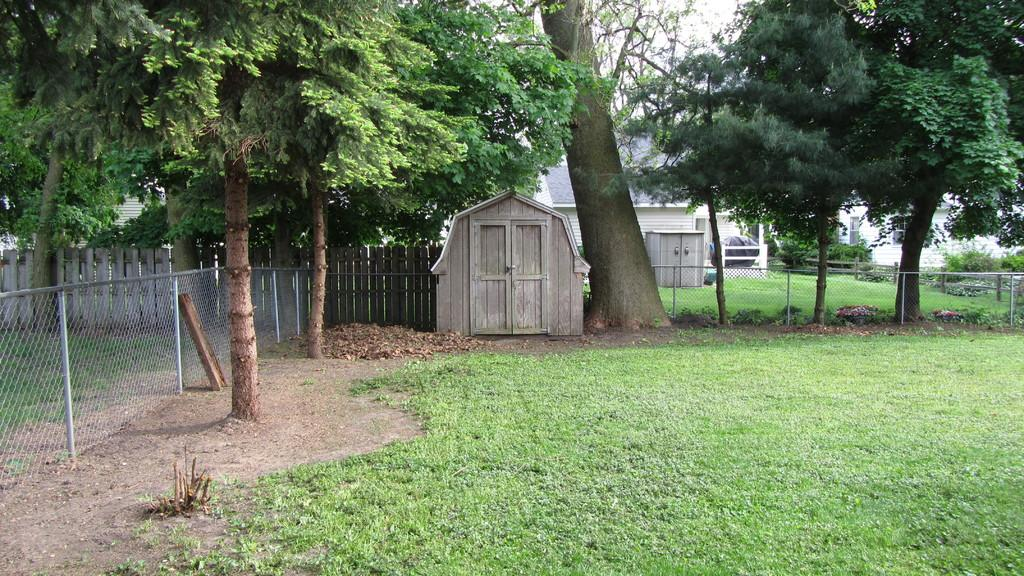What type of fencing is visible in the image? There is wooden fencing in the image. How many small huts can be seen in the image? There are 2 small huts in the image. What type of structure is also present in the image? There is a house in the image. What type of vegetation is present in the image? There are trees and plants in the image. What is the color of the grass in the image? The grass in the image is green. Where is the father standing in the image? There is no father present in the image. What type of performance is happening on the stage in the image? There is no stage present in the image. 